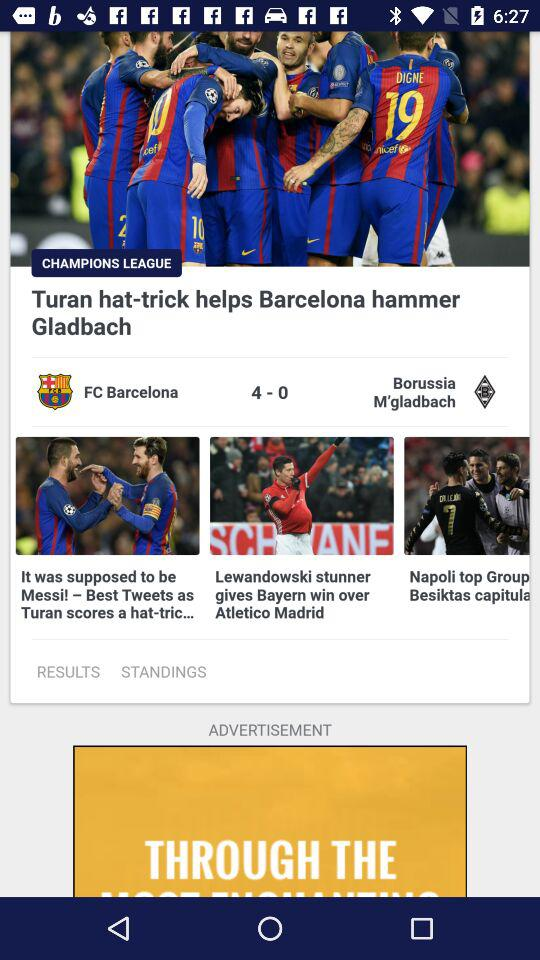How many more goals did Barcelona score than Borussia M'gladbach?
Answer the question using a single word or phrase. 4 